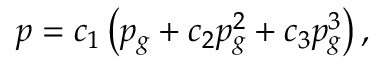Convert formula to latex. <formula><loc_0><loc_0><loc_500><loc_500>\begin{array} { r } { p = c _ { 1 } \left ( p _ { g } + c _ { 2 } p _ { g } ^ { 2 } + c _ { 3 } p _ { g } ^ { 3 } \right ) , } \end{array}</formula> 